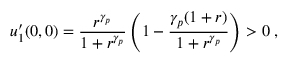<formula> <loc_0><loc_0><loc_500><loc_500>u _ { 1 } ^ { \prime } ( 0 , 0 ) = \frac { r ^ { \gamma _ { p } } } { 1 + r ^ { \gamma _ { p } } } \left ( 1 - \frac { \gamma _ { p } ( 1 + r ) } { 1 + r ^ { \gamma _ { p } } } \right ) > 0 \, ,</formula> 